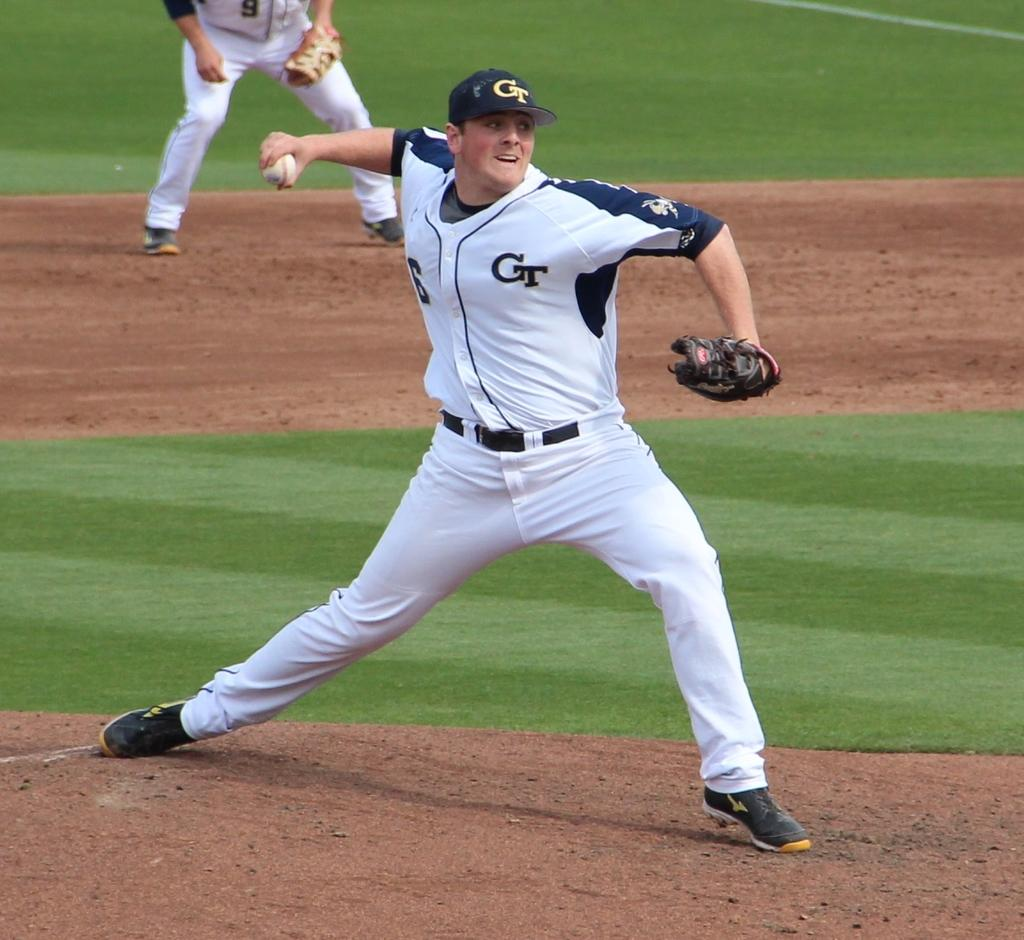Provide a one-sentence caption for the provided image. a baseball pitcher ready to throw a ball with CT on the uniform and the cap he's wearing. 